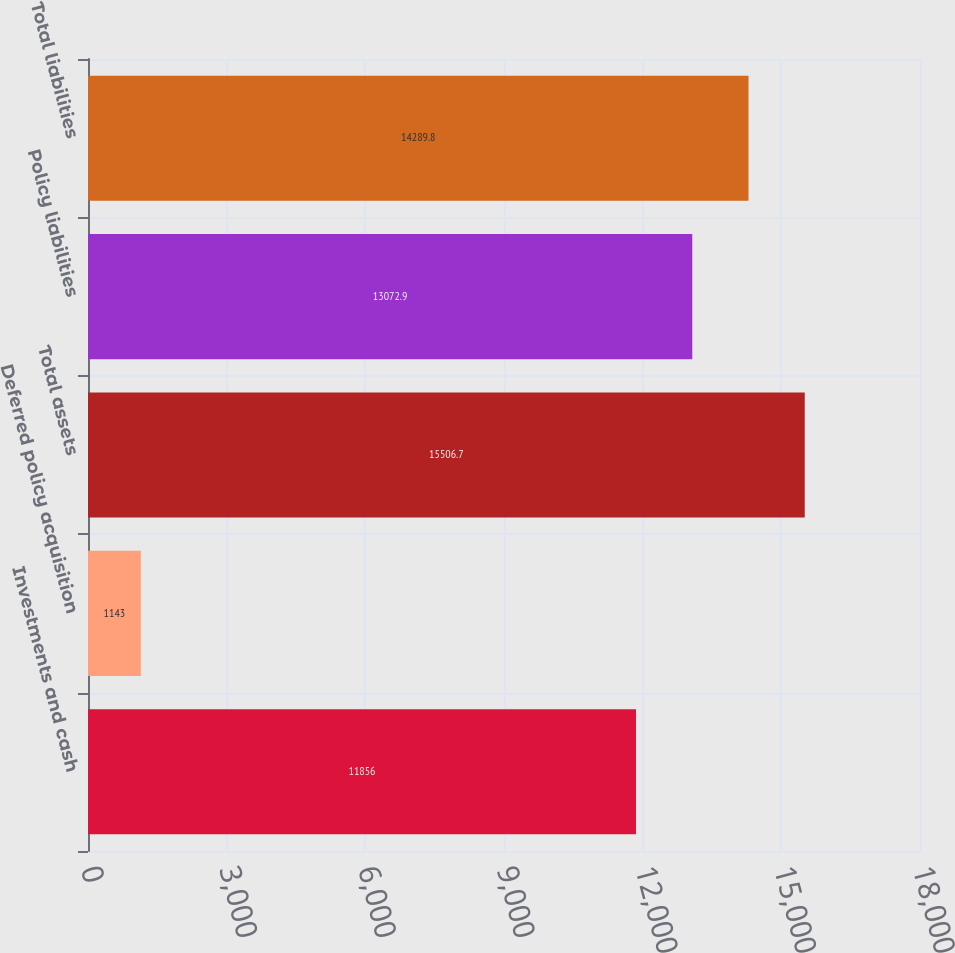Convert chart. <chart><loc_0><loc_0><loc_500><loc_500><bar_chart><fcel>Investments and cash<fcel>Deferred policy acquisition<fcel>Total assets<fcel>Policy liabilities<fcel>Total liabilities<nl><fcel>11856<fcel>1143<fcel>15506.7<fcel>13072.9<fcel>14289.8<nl></chart> 